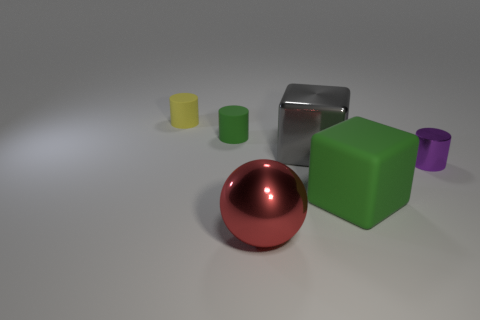If this image were a visual metaphor, what could it represent? If interpreted as a visual metaphor, the image might represent diversity and unity. The variety of shapes, colors, and textures symbolizes diverse elements, while their arrangement in proximity can depict the notion that different entities can coexist in harmony. The central red sphere could be seen as a unifying point or a common goal that brings the varied pieces together. 